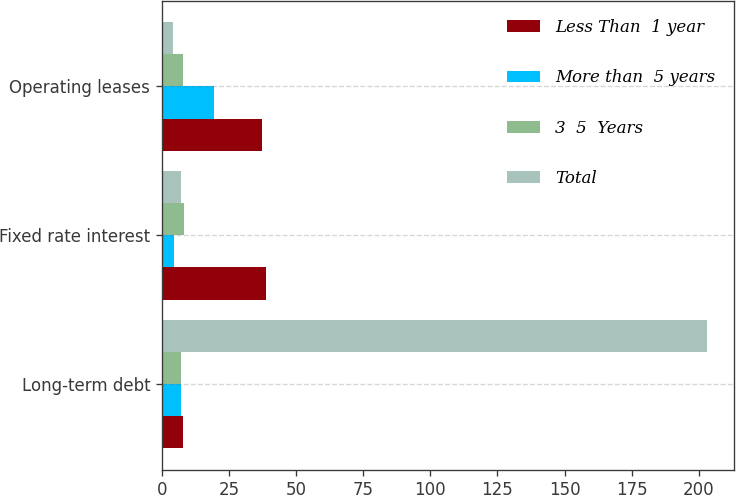Convert chart to OTSL. <chart><loc_0><loc_0><loc_500><loc_500><stacked_bar_chart><ecel><fcel>Long-term debt<fcel>Fixed rate interest<fcel>Operating leases<nl><fcel>Less Than  1 year<fcel>7.9<fcel>38.6<fcel>37.4<nl><fcel>More than  5 years<fcel>7.2<fcel>4.6<fcel>19.5<nl><fcel>3  5  Years<fcel>7.2<fcel>8.1<fcel>7.9<nl><fcel>Total<fcel>202.9<fcel>7.2<fcel>4.2<nl></chart> 